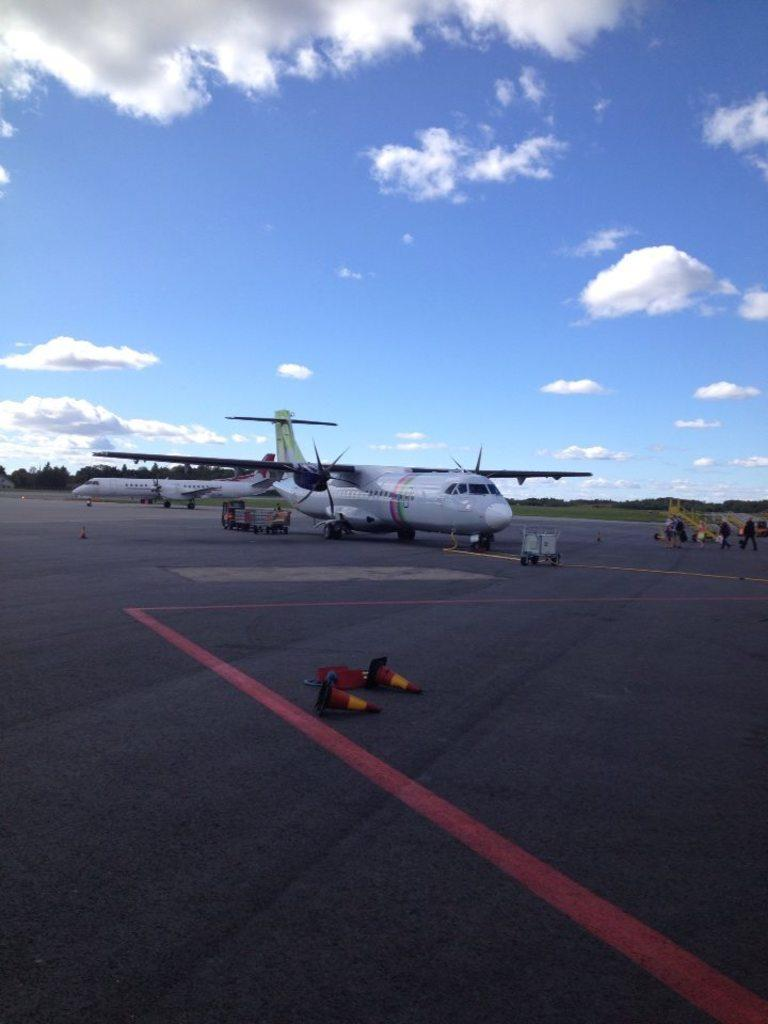What is happening on the road in the image? There are vehicles on the road, and traffic cones are present. Can you describe the vehicles on the road? The specific types of vehicles are not mentioned, but they are visible on the road. What else is present in the image besides the vehicles and traffic cones? Airplanes are visible on the surface, people are observable in the distance, there is grass in the background, trees are present in the background, and the sky is visible in the background with clouds. What type of oil is being used to print the airplanes in the image? There is no mention of oil or printing in the image; the airplanes are visible on the surface. What is the end result of the people observable in the distance? The image does not provide information about the end result or purpose of the people observable in the distance. 